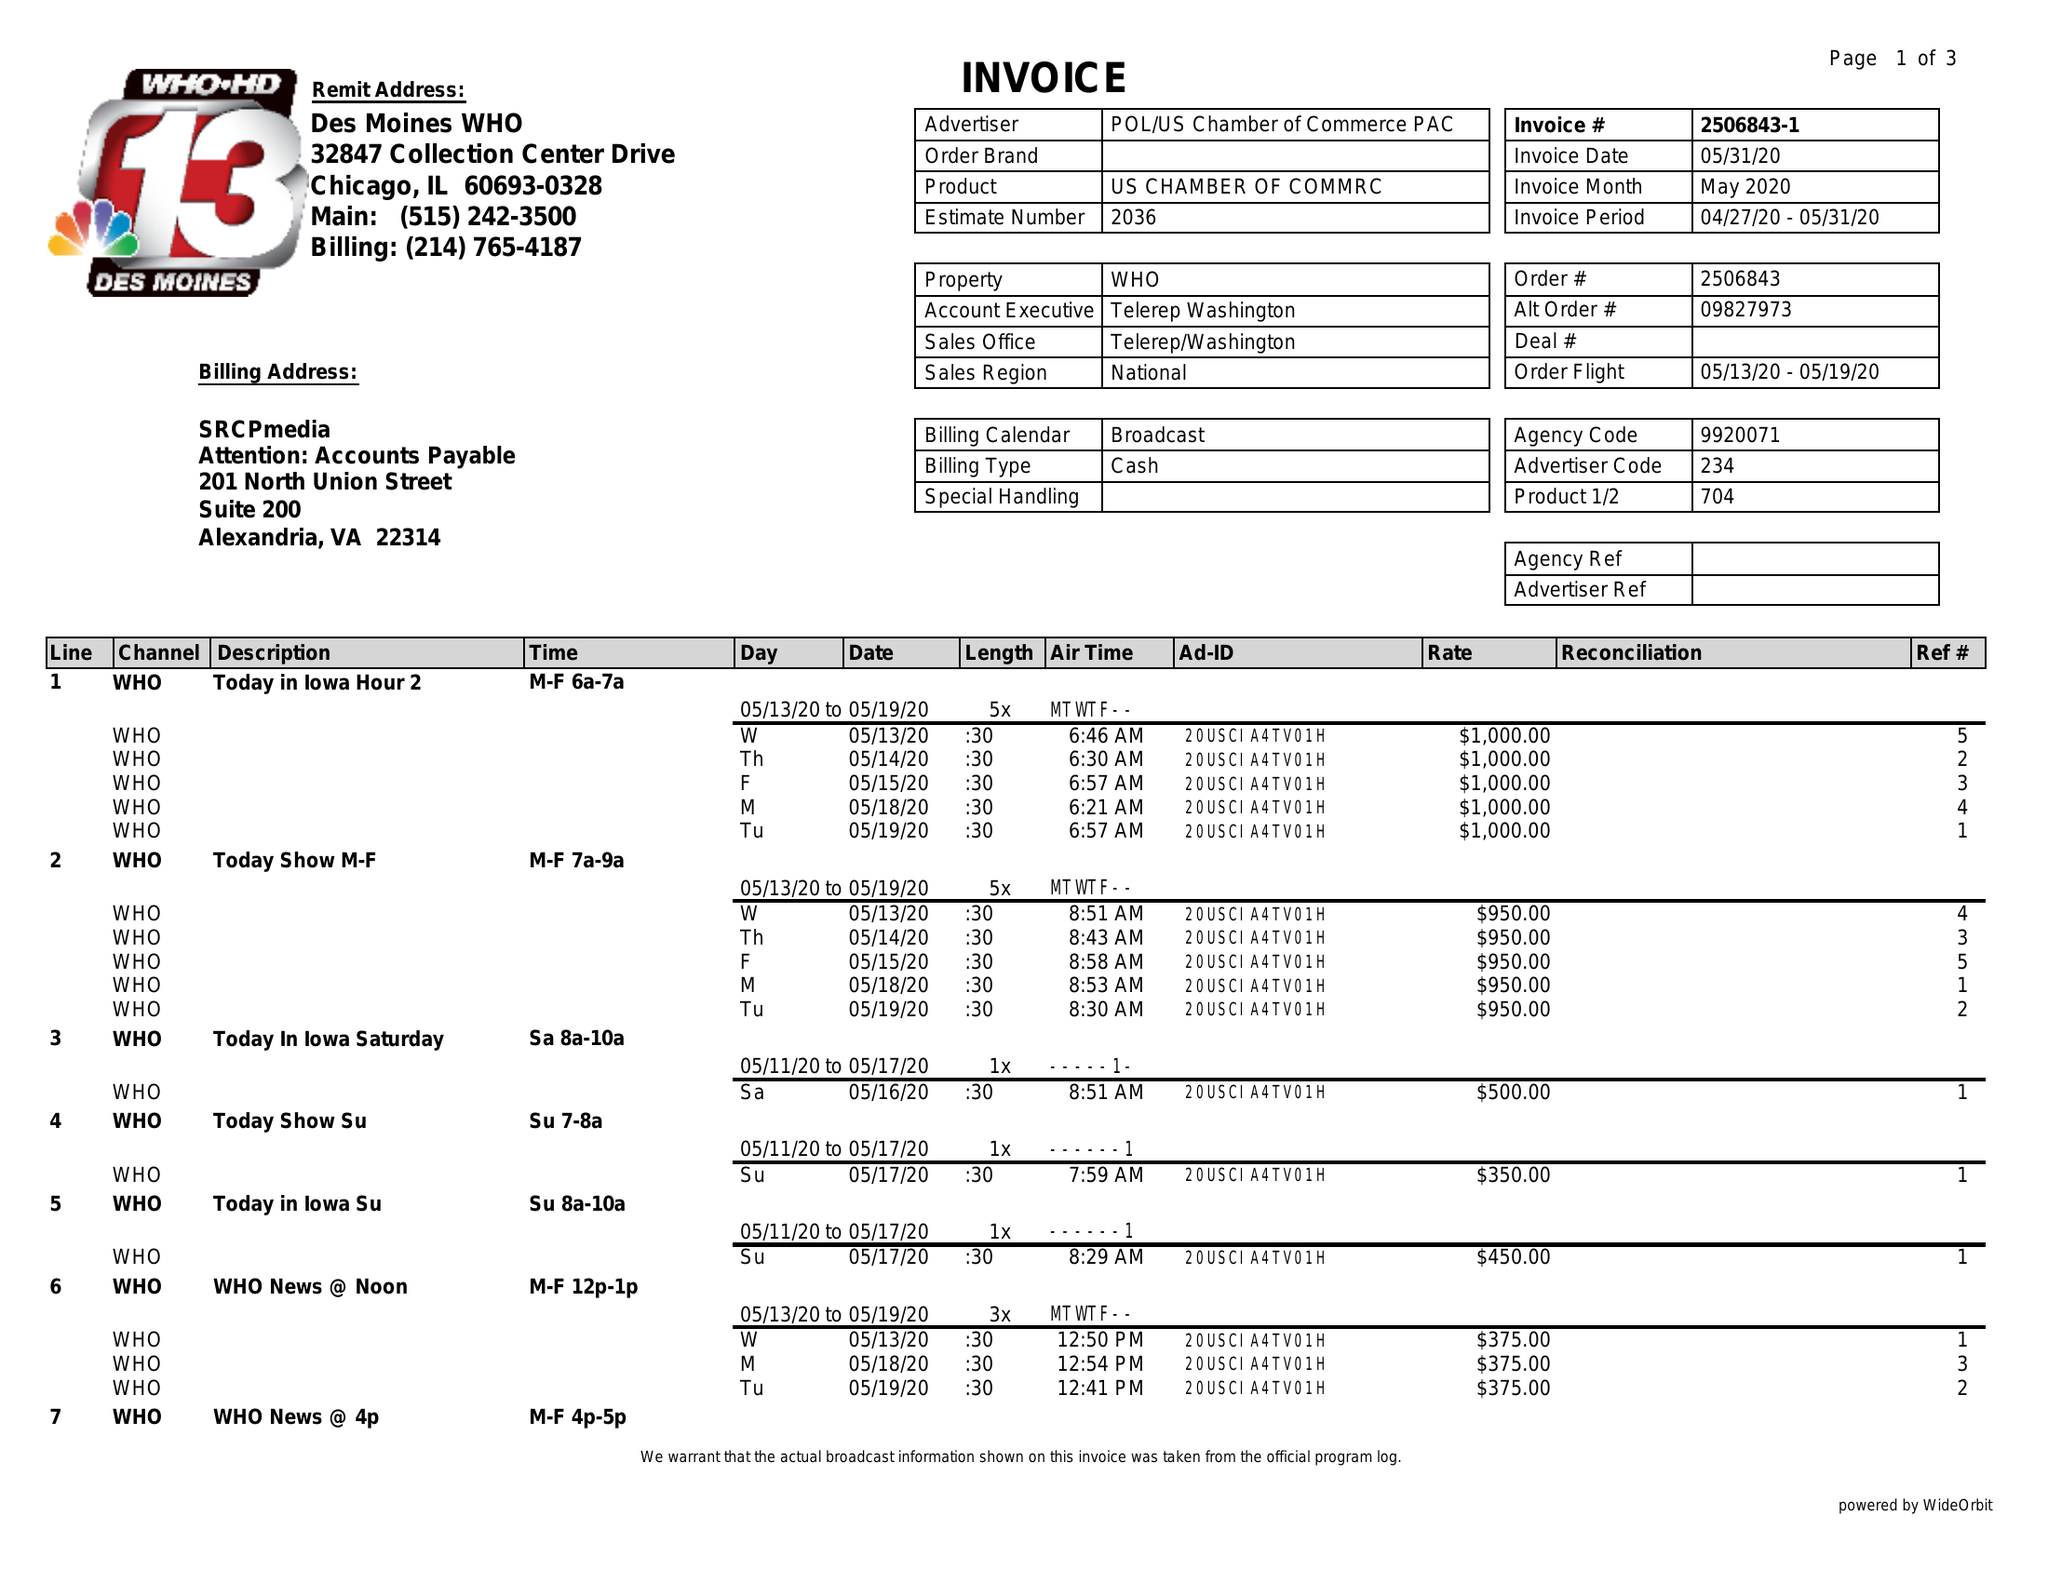What is the value for the advertiser?
Answer the question using a single word or phrase. POL/USCHAMBEROFCOMMERCEPAC 